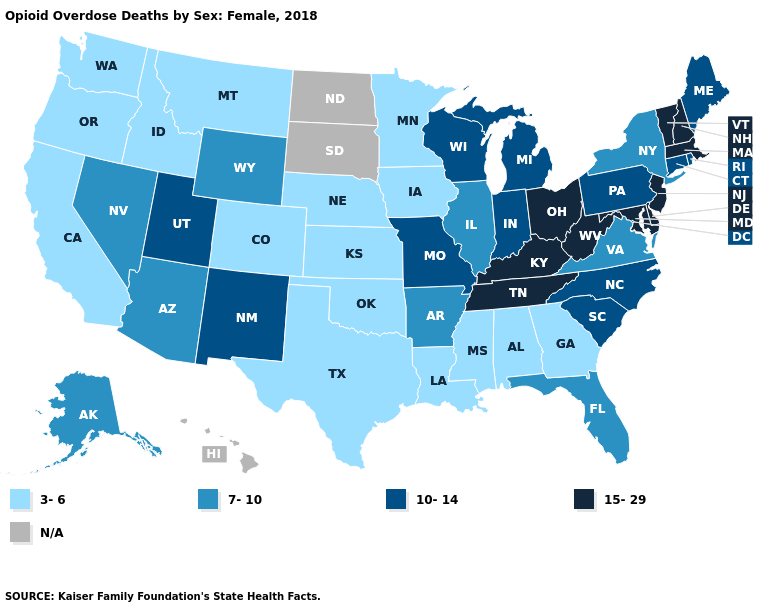What is the highest value in the USA?
Answer briefly. 15-29. What is the value of New Hampshire?
Keep it brief. 15-29. Name the states that have a value in the range N/A?
Answer briefly. Hawaii, North Dakota, South Dakota. What is the lowest value in states that border Maryland?
Give a very brief answer. 7-10. Does the map have missing data?
Concise answer only. Yes. Is the legend a continuous bar?
Short answer required. No. What is the lowest value in the Northeast?
Answer briefly. 7-10. What is the highest value in the USA?
Concise answer only. 15-29. Does the map have missing data?
Give a very brief answer. Yes. What is the lowest value in the Northeast?
Write a very short answer. 7-10. What is the value of Washington?
Give a very brief answer. 3-6. Name the states that have a value in the range 10-14?
Write a very short answer. Connecticut, Indiana, Maine, Michigan, Missouri, New Mexico, North Carolina, Pennsylvania, Rhode Island, South Carolina, Utah, Wisconsin. 